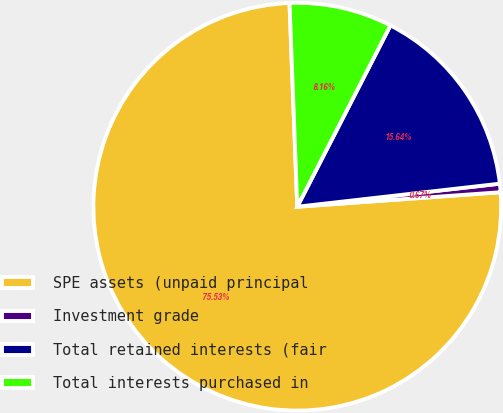Convert chart. <chart><loc_0><loc_0><loc_500><loc_500><pie_chart><fcel>SPE assets (unpaid principal<fcel>Investment grade<fcel>Total retained interests (fair<fcel>Total interests purchased in<nl><fcel>75.52%<fcel>0.67%<fcel>15.64%<fcel>8.16%<nl></chart> 